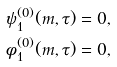Convert formula to latex. <formula><loc_0><loc_0><loc_500><loc_500>& \psi _ { 1 } ^ { ( 0 ) } ( m , \tau ) = 0 , \\ & \phi _ { 1 } ^ { ( 0 ) } ( m , \tau ) = 0 ,</formula> 